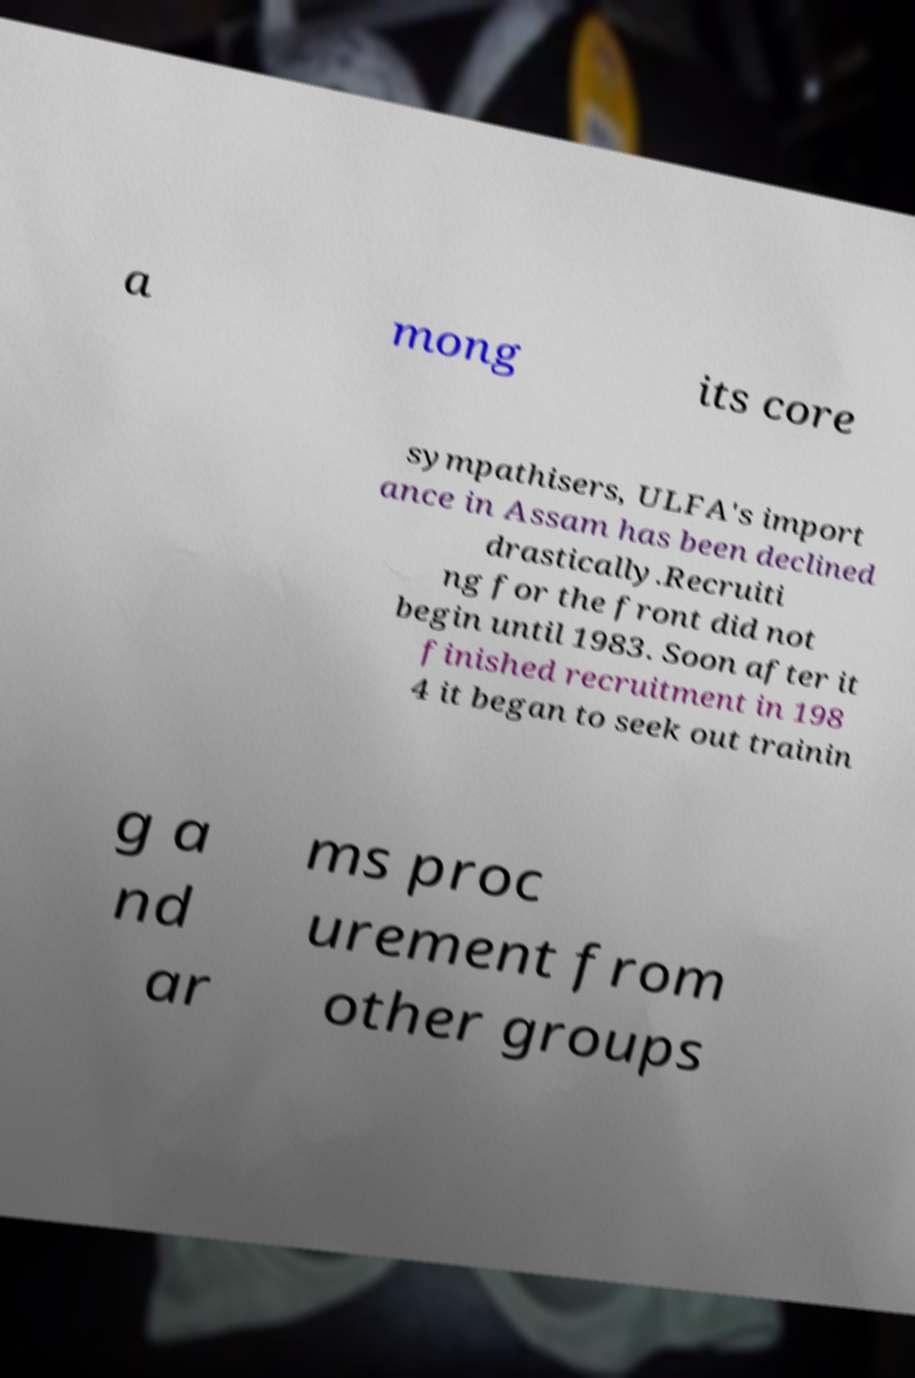Please read and relay the text visible in this image. What does it say? a mong its core sympathisers, ULFA's import ance in Assam has been declined drastically.Recruiti ng for the front did not begin until 1983. Soon after it finished recruitment in 198 4 it began to seek out trainin g a nd ar ms proc urement from other groups 